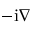<formula> <loc_0><loc_0><loc_500><loc_500>- i \nabla</formula> 